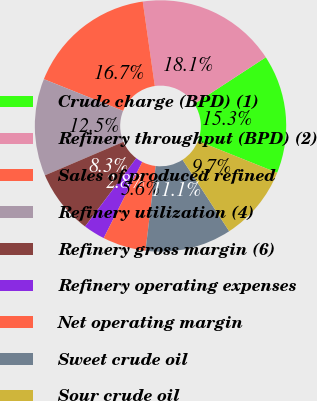Convert chart. <chart><loc_0><loc_0><loc_500><loc_500><pie_chart><fcel>Crude charge (BPD) (1)<fcel>Refinery throughput (BPD) (2)<fcel>Sales of produced refined<fcel>Refinery utilization (4)<fcel>Refinery gross margin (6)<fcel>Refinery operating expenses<fcel>Net operating margin<fcel>Sweet crude oil<fcel>Sour crude oil<nl><fcel>15.28%<fcel>18.06%<fcel>16.67%<fcel>12.5%<fcel>8.33%<fcel>2.78%<fcel>5.56%<fcel>11.11%<fcel>9.72%<nl></chart> 